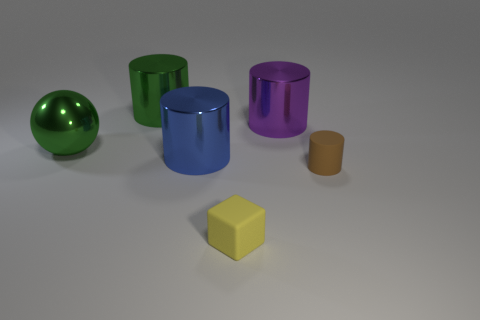Subtract all large green cylinders. How many cylinders are left? 3 Add 3 large metal balls. How many objects exist? 9 Subtract all green cylinders. How many cylinders are left? 3 Subtract all cubes. How many objects are left? 5 Subtract 2 cylinders. How many cylinders are left? 2 Subtract all gray cylinders. Subtract all green spheres. How many cylinders are left? 4 Add 4 red rubber blocks. How many red rubber blocks exist? 4 Subtract 0 cyan cubes. How many objects are left? 6 Subtract all big blue metal things. Subtract all large purple shiny objects. How many objects are left? 4 Add 6 tiny brown things. How many tiny brown things are left? 7 